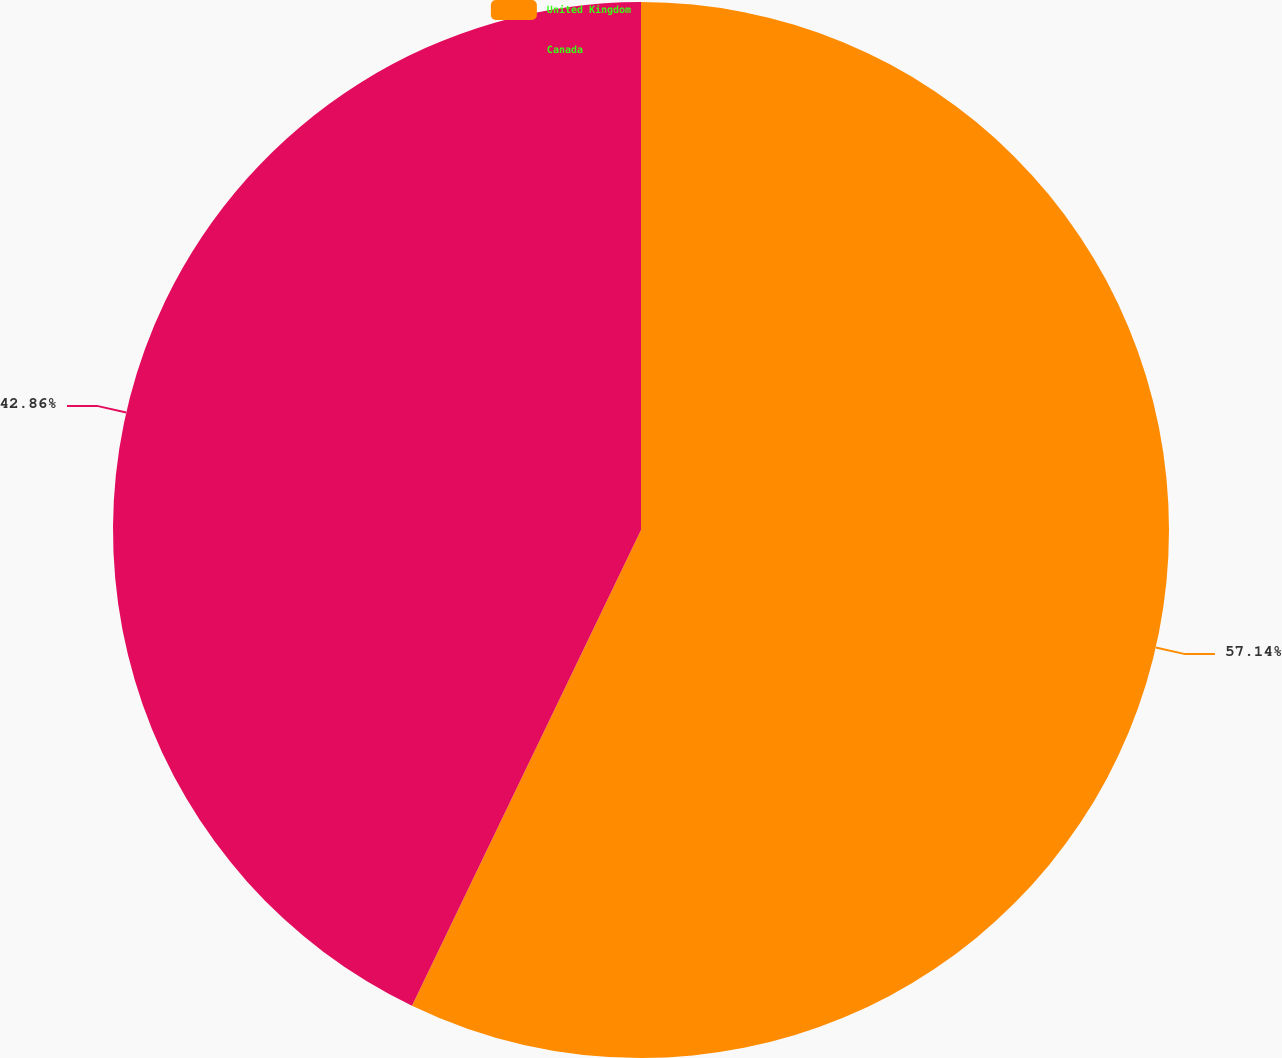<chart> <loc_0><loc_0><loc_500><loc_500><pie_chart><fcel>United Kingdom<fcel>Canada<nl><fcel>57.14%<fcel>42.86%<nl></chart> 